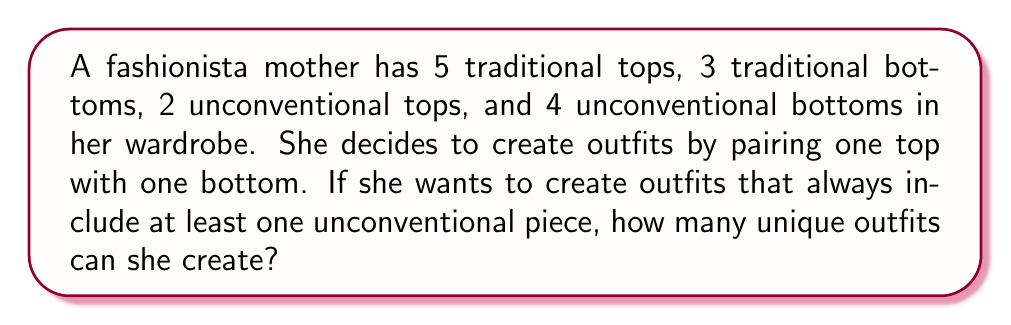Give your solution to this math problem. Let's approach this step-by-step:

1) First, let's calculate the total number of outfits with at least one unconventional piece:

   a) Outfits with unconventional top and traditional bottom:
      $2 \times 3 = 6$ outfits

   b) Outfits with traditional top and unconventional bottom:
      $5 \times 4 = 20$ outfits

   c) Outfits with both pieces unconventional:
      $2 \times 4 = 8$ outfits

2) Now, we need to sum up all these possibilities:

   $$(2 \times 3) + (5 \times 4) + (2 \times 4) = 6 + 20 + 8 = 34$$

3) We can verify this result using the principle of inclusion-exclusion:

   a) Total outfits: $(5+2) \times (3+4) = 7 \times 7 = 49$
   b) Outfits with both pieces traditional: $5 \times 3 = 15$
   c) Outfits with at least one unconventional piece: $49 - 15 = 34$

Therefore, the fashionista mother can create 34 unique outfits that include at least one unconventional piece.
Answer: 34 outfits 